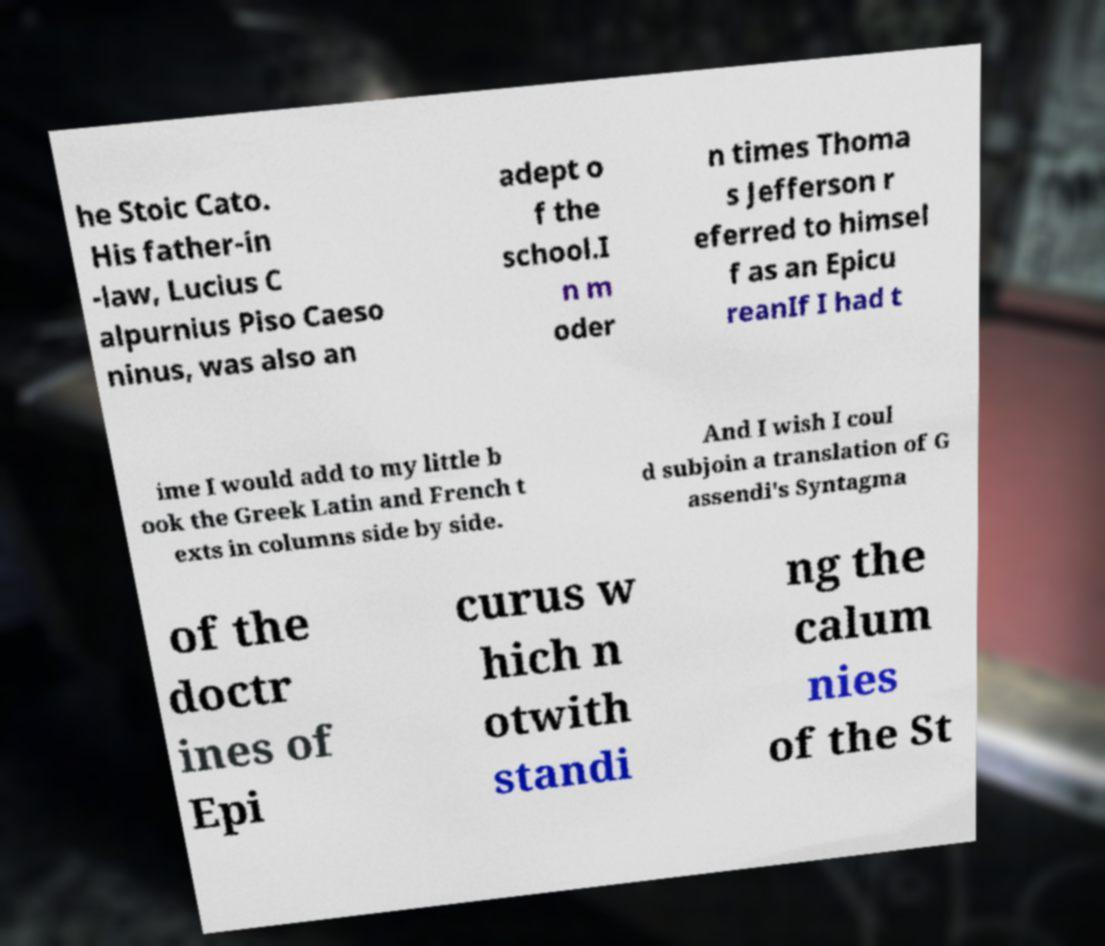Please identify and transcribe the text found in this image. he Stoic Cato. His father-in -law, Lucius C alpurnius Piso Caeso ninus, was also an adept o f the school.I n m oder n times Thoma s Jefferson r eferred to himsel f as an Epicu reanIf I had t ime I would add to my little b ook the Greek Latin and French t exts in columns side by side. And I wish I coul d subjoin a translation of G assendi's Syntagma of the doctr ines of Epi curus w hich n otwith standi ng the calum nies of the St 